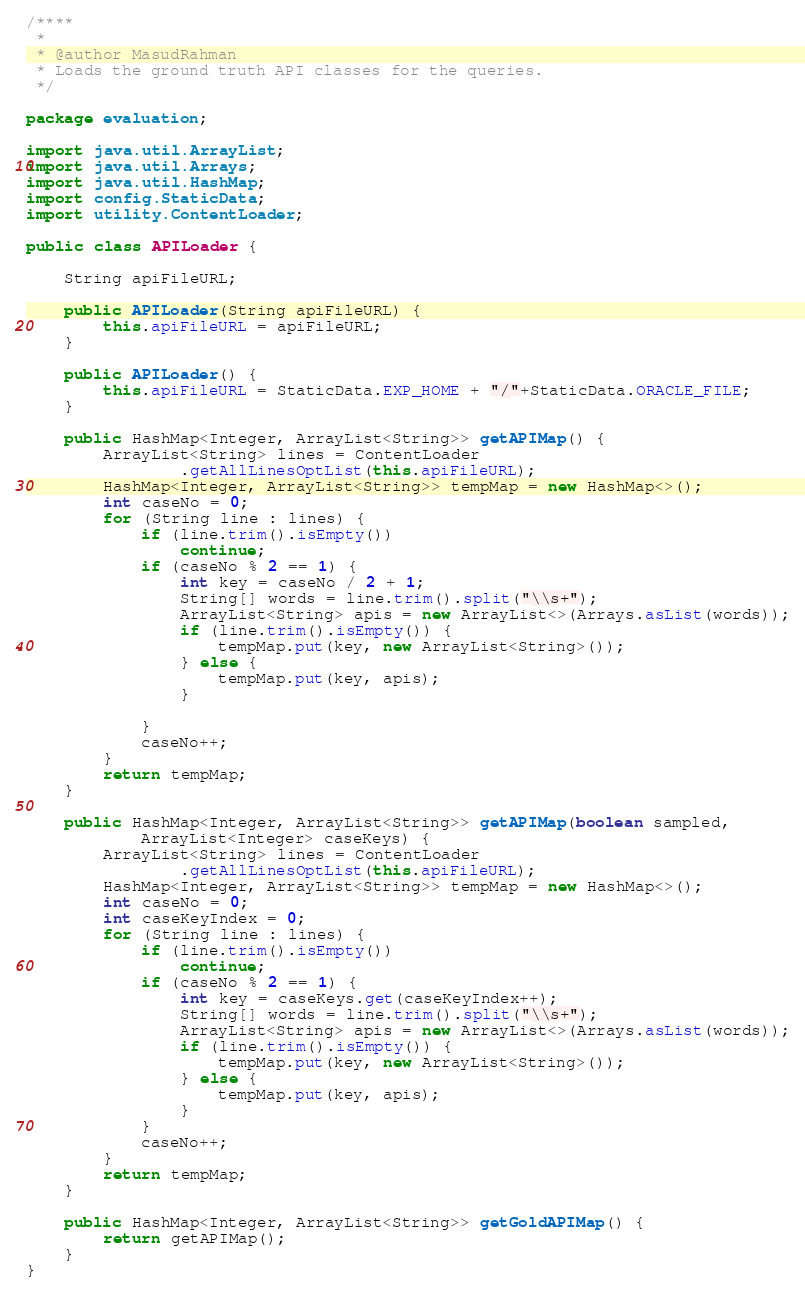Convert code to text. <code><loc_0><loc_0><loc_500><loc_500><_Java_>
/****
 * 
 * @author MasudRahman
 * Loads the ground truth API classes for the queries.
 */

package evaluation;

import java.util.ArrayList;
import java.util.Arrays;
import java.util.HashMap;
import config.StaticData;
import utility.ContentLoader;

public class APILoader {

	String apiFileURL;

	public APILoader(String apiFileURL) {
		this.apiFileURL = apiFileURL;
	}

	public APILoader() {
		this.apiFileURL = StaticData.EXP_HOME + "/"+StaticData.ORACLE_FILE;
	}

	public HashMap<Integer, ArrayList<String>> getAPIMap() {
		ArrayList<String> lines = ContentLoader
				.getAllLinesOptList(this.apiFileURL);
		HashMap<Integer, ArrayList<String>> tempMap = new HashMap<>();
		int caseNo = 0;
		for (String line : lines) {
			if (line.trim().isEmpty())
				continue;
			if (caseNo % 2 == 1) {
				int key = caseNo / 2 + 1;
				String[] words = line.trim().split("\\s+");
				ArrayList<String> apis = new ArrayList<>(Arrays.asList(words));
				if (line.trim().isEmpty()) {
					tempMap.put(key, new ArrayList<String>());
				} else {
					tempMap.put(key, apis);
				}

			}
			caseNo++;
		}
		return tempMap;
	}

	public HashMap<Integer, ArrayList<String>> getAPIMap(boolean sampled,
			ArrayList<Integer> caseKeys) {
		ArrayList<String> lines = ContentLoader
				.getAllLinesOptList(this.apiFileURL);
		HashMap<Integer, ArrayList<String>> tempMap = new HashMap<>();
		int caseNo = 0;
		int caseKeyIndex = 0;
		for (String line : lines) {
			if (line.trim().isEmpty())
				continue;
			if (caseNo % 2 == 1) {
				int key = caseKeys.get(caseKeyIndex++);
				String[] words = line.trim().split("\\s+");
				ArrayList<String> apis = new ArrayList<>(Arrays.asList(words));
				if (line.trim().isEmpty()) {
					tempMap.put(key, new ArrayList<String>());
				} else {
					tempMap.put(key, apis);
				}
			}
			caseNo++;
		}
		return tempMap;
	}

	public HashMap<Integer, ArrayList<String>> getGoldAPIMap() {
		return getAPIMap();
	}
}
</code> 